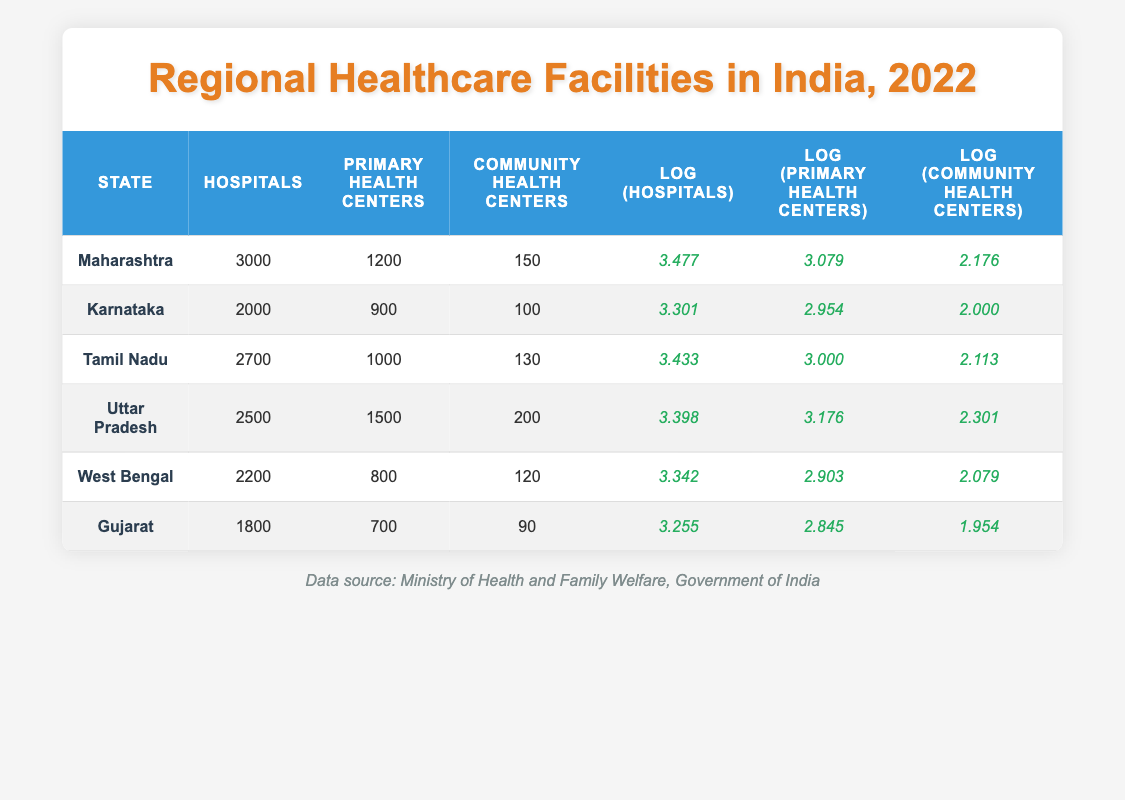What is the total number of hospitals in Uttar Pradesh and Gujarat combined? The number of hospitals in Uttar Pradesh is 2500 and in Gujarat, it is 1800. Adding these values together gives 2500 + 1800 = 4300.
Answer: 4300 Which state has the highest number of Primary Health Centers? By looking at the table, Uttar Pradesh has 1500 Primary Health Centers, which is higher than other states listed.
Answer: Uttar Pradesh True or False: Karnataka has more Community Health Centers than Tamil Nadu. Karnataka has 100 Community Health Centers, while Tamil Nadu has 130. Since 100 is less than 130, the statement is false.
Answer: False What is the average number of hospitals across all states listed? The total number of hospitals is the sum of hospitals in each state: 3000 + 2000 + 2700 + 2500 + 2200 + 1800 = 17200. There are 6 states, so the average is 17200 / 6 = 2866.67.
Answer: 2866.67 Which region has the lowest logarithmic value for Community Health Centers? Upon checking the Log_Community_Health_Centers column, Gujarat has the lowest value of 1.954, which is less than the others.
Answer: Gujarat 